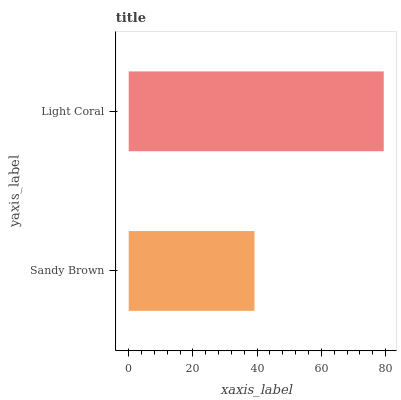Is Sandy Brown the minimum?
Answer yes or no. Yes. Is Light Coral the maximum?
Answer yes or no. Yes. Is Light Coral the minimum?
Answer yes or no. No. Is Light Coral greater than Sandy Brown?
Answer yes or no. Yes. Is Sandy Brown less than Light Coral?
Answer yes or no. Yes. Is Sandy Brown greater than Light Coral?
Answer yes or no. No. Is Light Coral less than Sandy Brown?
Answer yes or no. No. Is Light Coral the high median?
Answer yes or no. Yes. Is Sandy Brown the low median?
Answer yes or no. Yes. Is Sandy Brown the high median?
Answer yes or no. No. Is Light Coral the low median?
Answer yes or no. No. 